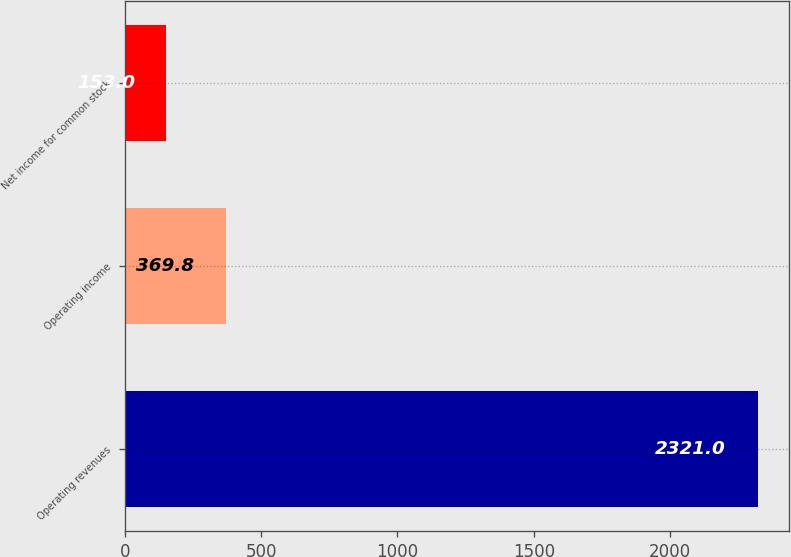Convert chart. <chart><loc_0><loc_0><loc_500><loc_500><bar_chart><fcel>Operating revenues<fcel>Operating income<fcel>Net income for common stock<nl><fcel>2321<fcel>369.8<fcel>153<nl></chart> 